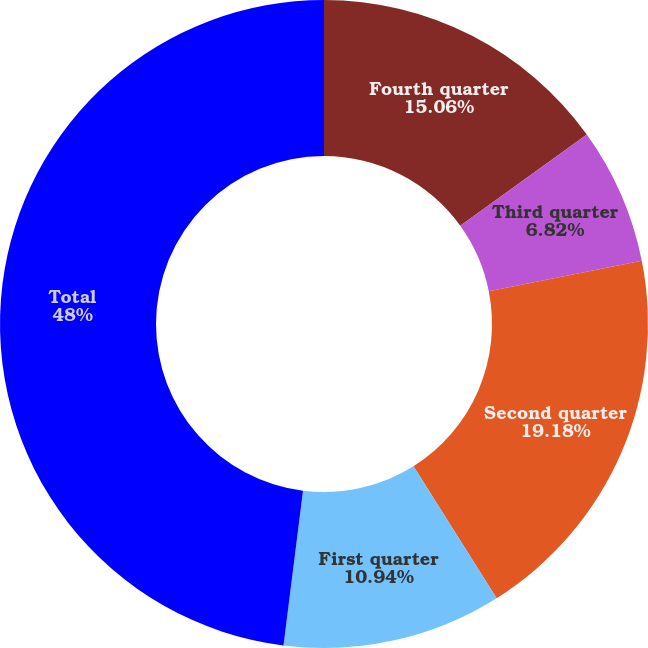<chart> <loc_0><loc_0><loc_500><loc_500><pie_chart><fcel>Fourth quarter<fcel>Third quarter<fcel>Second quarter<fcel>First quarter<fcel>Total<nl><fcel>15.06%<fcel>6.82%<fcel>19.18%<fcel>10.94%<fcel>48.01%<nl></chart> 